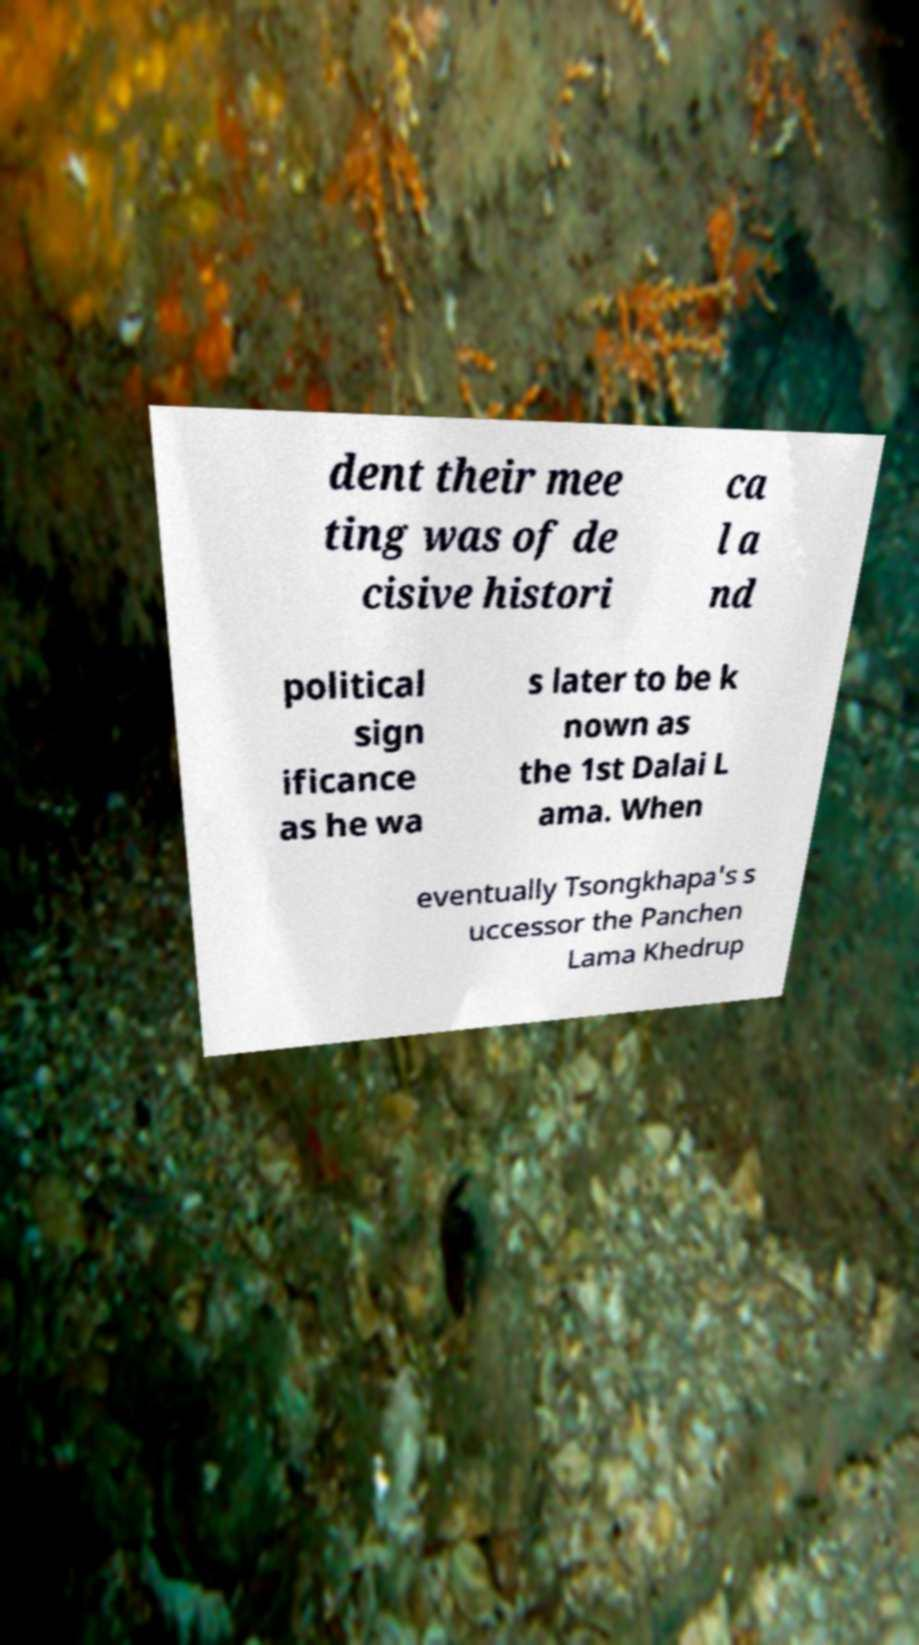Please identify and transcribe the text found in this image. dent their mee ting was of de cisive histori ca l a nd political sign ificance as he wa s later to be k nown as the 1st Dalai L ama. When eventually Tsongkhapa's s uccessor the Panchen Lama Khedrup 